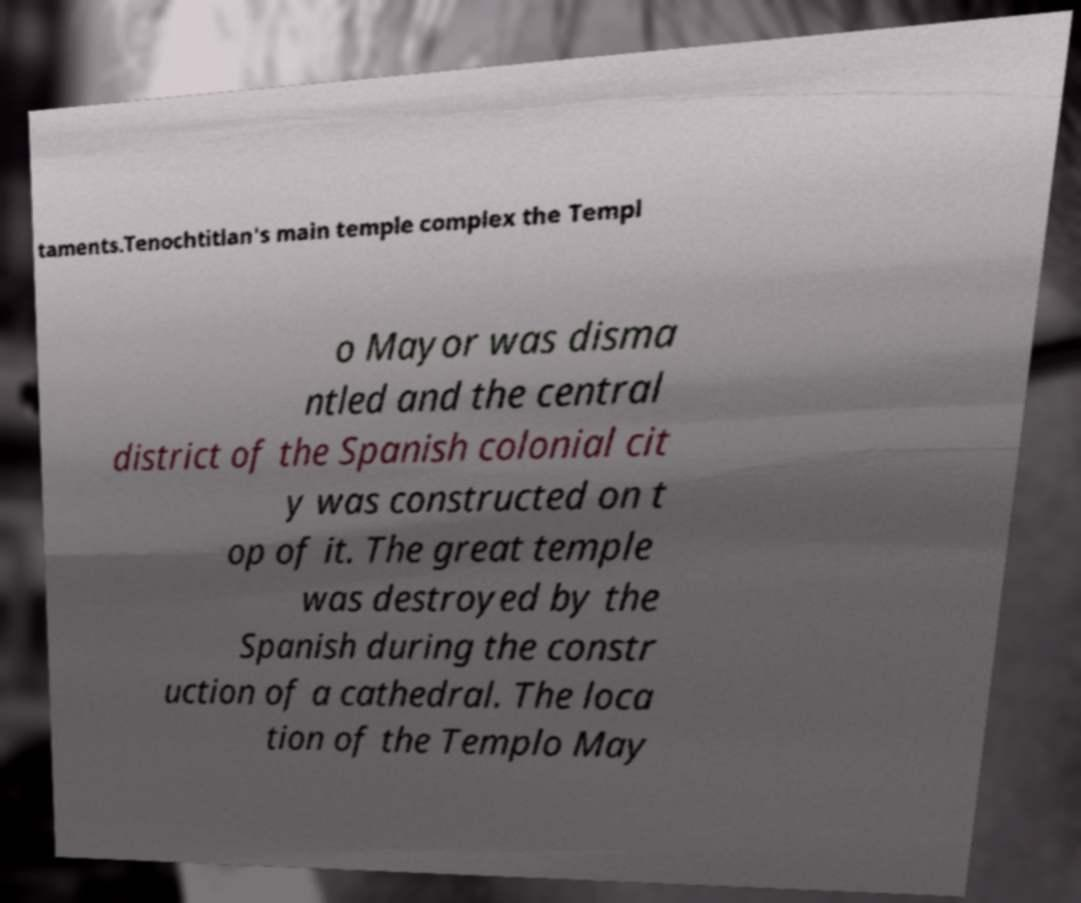Please read and relay the text visible in this image. What does it say? taments.Tenochtitlan's main temple complex the Templ o Mayor was disma ntled and the central district of the Spanish colonial cit y was constructed on t op of it. The great temple was destroyed by the Spanish during the constr uction of a cathedral. The loca tion of the Templo May 